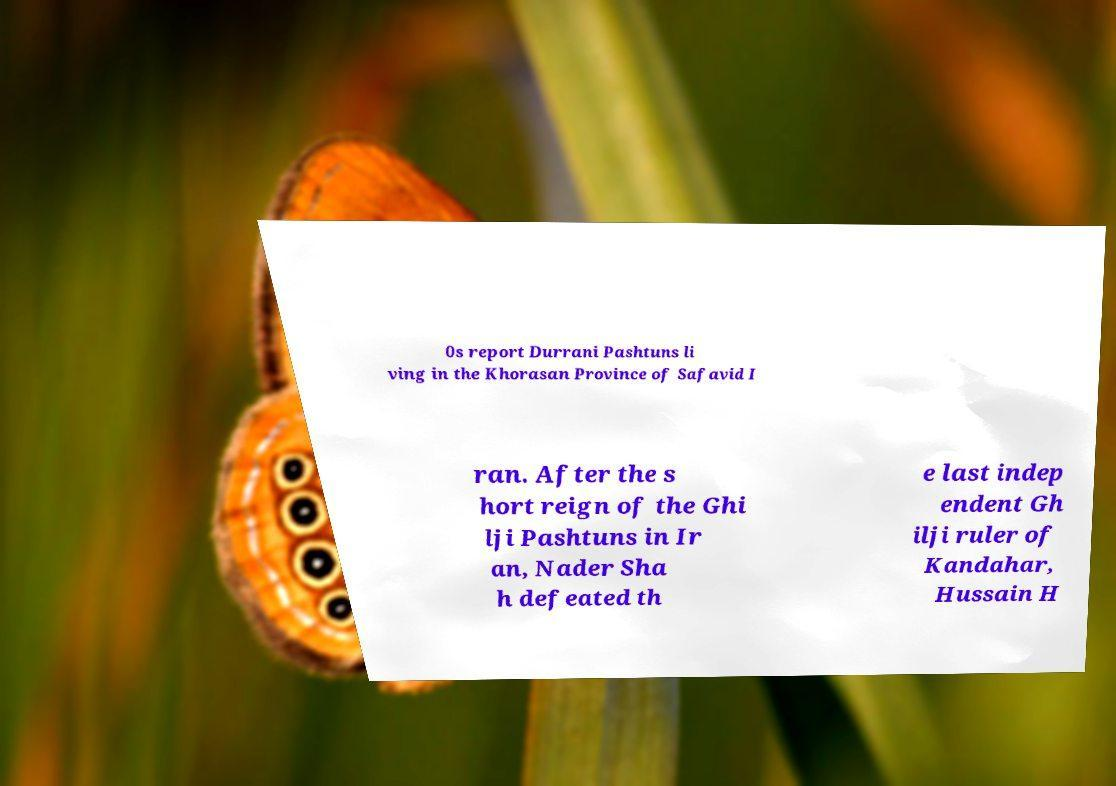There's text embedded in this image that I need extracted. Can you transcribe it verbatim? 0s report Durrani Pashtuns li ving in the Khorasan Province of Safavid I ran. After the s hort reign of the Ghi lji Pashtuns in Ir an, Nader Sha h defeated th e last indep endent Gh ilji ruler of Kandahar, Hussain H 